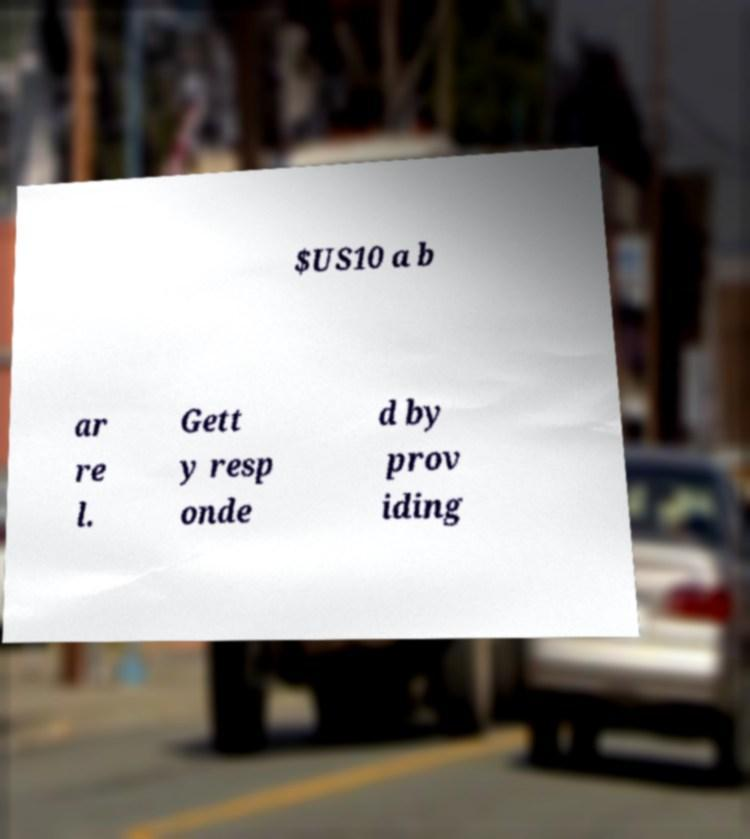Can you read and provide the text displayed in the image?This photo seems to have some interesting text. Can you extract and type it out for me? $US10 a b ar re l. Gett y resp onde d by prov iding 